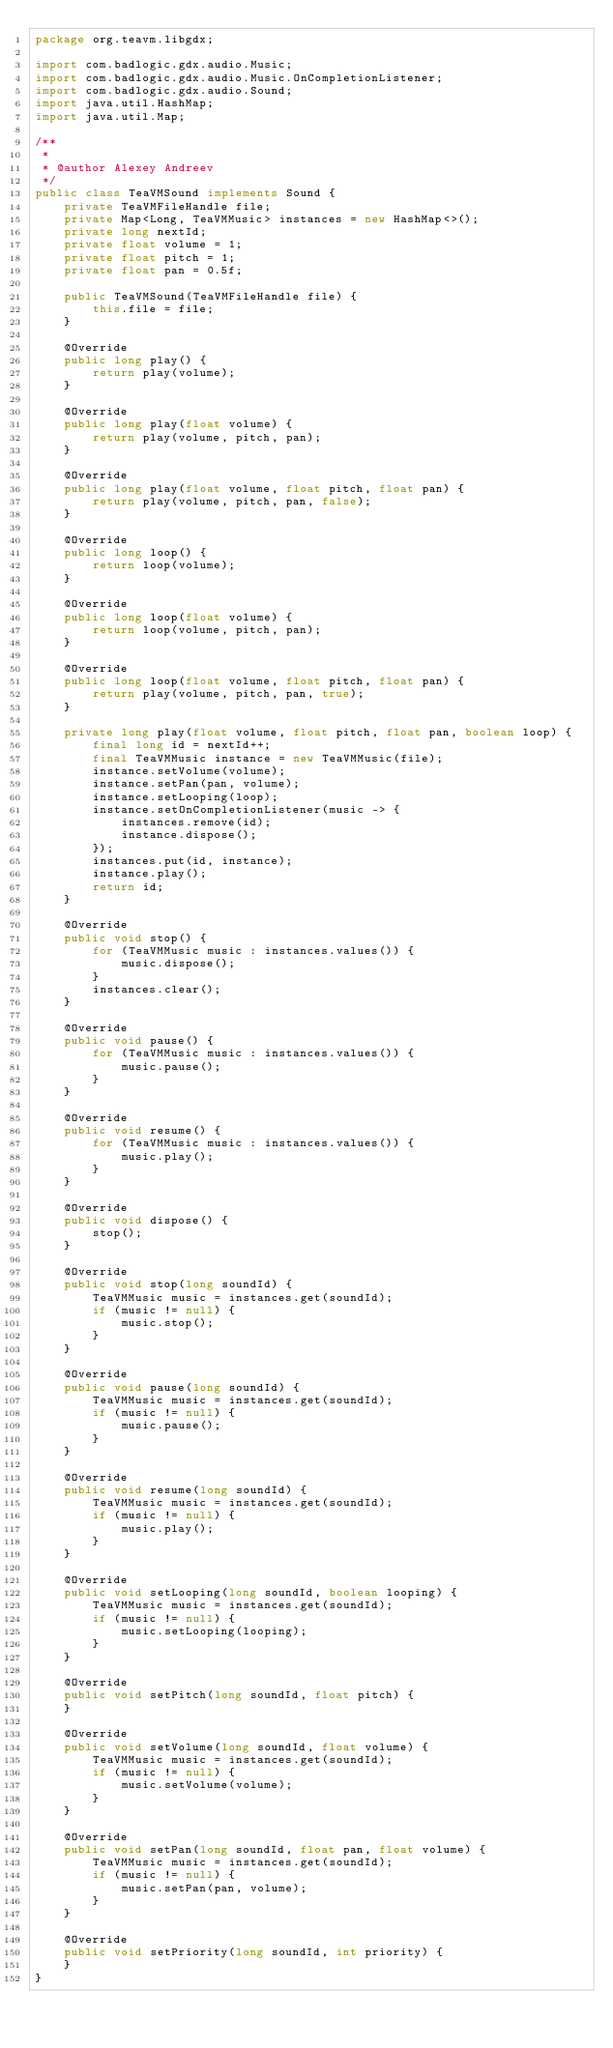Convert code to text. <code><loc_0><loc_0><loc_500><loc_500><_Java_>package org.teavm.libgdx;

import com.badlogic.gdx.audio.Music;
import com.badlogic.gdx.audio.Music.OnCompletionListener;
import com.badlogic.gdx.audio.Sound;
import java.util.HashMap;
import java.util.Map;

/**
 *
 * @author Alexey Andreev
 */
public class TeaVMSound implements Sound {
    private TeaVMFileHandle file;
    private Map<Long, TeaVMMusic> instances = new HashMap<>();
    private long nextId;
    private float volume = 1;
    private float pitch = 1;
    private float pan = 0.5f;

    public TeaVMSound(TeaVMFileHandle file) {
        this.file = file;
    }

    @Override
    public long play() {
        return play(volume);
    }

    @Override
    public long play(float volume) {
        return play(volume, pitch, pan);
    }

    @Override
    public long play(float volume, float pitch, float pan) {
        return play(volume, pitch, pan, false);
    }

    @Override
    public long loop() {
        return loop(volume);
    }

    @Override
    public long loop(float volume) {
        return loop(volume, pitch, pan);
    }

    @Override
    public long loop(float volume, float pitch, float pan) {
        return play(volume, pitch, pan, true);
    }

    private long play(float volume, float pitch, float pan, boolean loop) {
        final long id = nextId++;
        final TeaVMMusic instance = new TeaVMMusic(file);
        instance.setVolume(volume);
        instance.setPan(pan, volume);
        instance.setLooping(loop);
        instance.setOnCompletionListener(music -> {
            instances.remove(id);
            instance.dispose();
        });
        instances.put(id, instance);
        instance.play();
        return id;
    }

    @Override
    public void stop() {
        for (TeaVMMusic music : instances.values()) {
            music.dispose();
        }
        instances.clear();
    }

    @Override
    public void pause() {
        for (TeaVMMusic music : instances.values()) {
            music.pause();
        }
    }

    @Override
    public void resume() {
        for (TeaVMMusic music : instances.values()) {
            music.play();
        }
    }

    @Override
    public void dispose() {
        stop();
    }

    @Override
    public void stop(long soundId) {
        TeaVMMusic music = instances.get(soundId);
        if (music != null) {
            music.stop();
        }
    }

    @Override
    public void pause(long soundId) {
        TeaVMMusic music = instances.get(soundId);
        if (music != null) {
            music.pause();
        }
    }

    @Override
    public void resume(long soundId) {
        TeaVMMusic music = instances.get(soundId);
        if (music != null) {
            music.play();
        }
    }

    @Override
    public void setLooping(long soundId, boolean looping) {
        TeaVMMusic music = instances.get(soundId);
        if (music != null) {
            music.setLooping(looping);
        }
    }

    @Override
    public void setPitch(long soundId, float pitch) {
    }

    @Override
    public void setVolume(long soundId, float volume) {
        TeaVMMusic music = instances.get(soundId);
        if (music != null) {
            music.setVolume(volume);
        }
    }

    @Override
    public void setPan(long soundId, float pan, float volume) {
        TeaVMMusic music = instances.get(soundId);
        if (music != null) {
            music.setPan(pan, volume);
        }
    }

    @Override
    public void setPriority(long soundId, int priority) {
    }
}
</code> 